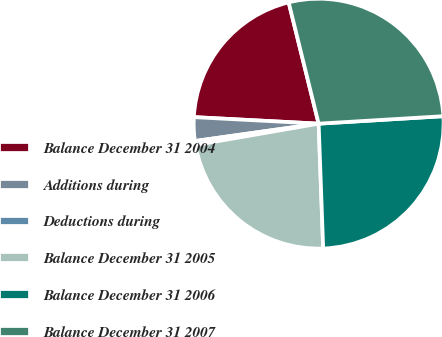<chart> <loc_0><loc_0><loc_500><loc_500><pie_chart><fcel>Balance December 31 2004<fcel>Additions during<fcel>Deductions during<fcel>Balance December 31 2005<fcel>Balance December 31 2006<fcel>Balance December 31 2007<nl><fcel>20.31%<fcel>3.05%<fcel>0.52%<fcel>22.84%<fcel>25.37%<fcel>27.9%<nl></chart> 